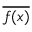<formula> <loc_0><loc_0><loc_500><loc_500>\overline { f ( x ) }</formula> 